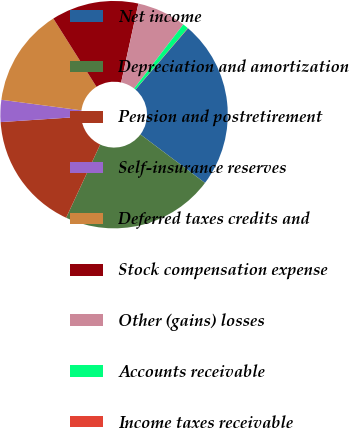<chart> <loc_0><loc_0><loc_500><loc_500><pie_chart><fcel>Net income<fcel>Depreciation and amortization<fcel>Pension and postretirement<fcel>Self-insurance reserves<fcel>Deferred taxes credits and<fcel>Stock compensation expense<fcel>Other (gains) losses<fcel>Accounts receivable<fcel>Income taxes receivable<nl><fcel>23.98%<fcel>21.67%<fcel>17.03%<fcel>3.13%<fcel>13.94%<fcel>12.4%<fcel>6.99%<fcel>0.81%<fcel>0.04%<nl></chart> 